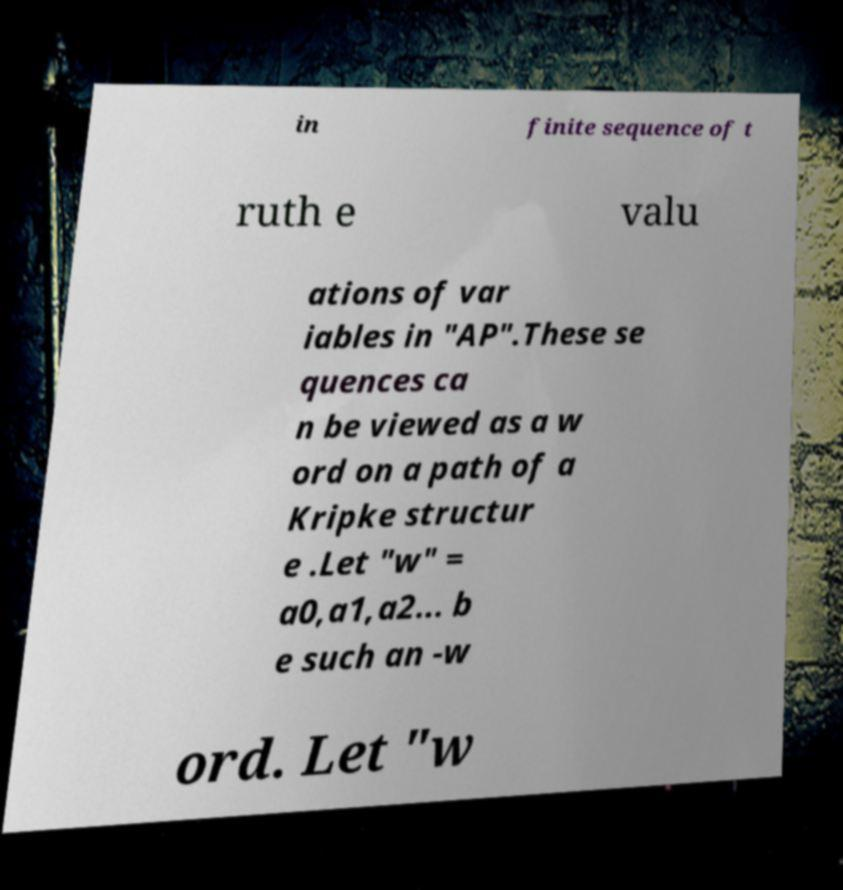Can you read and provide the text displayed in the image?This photo seems to have some interesting text. Can you extract and type it out for me? in finite sequence of t ruth e valu ations of var iables in "AP".These se quences ca n be viewed as a w ord on a path of a Kripke structur e .Let "w" = a0,a1,a2... b e such an -w ord. Let "w 